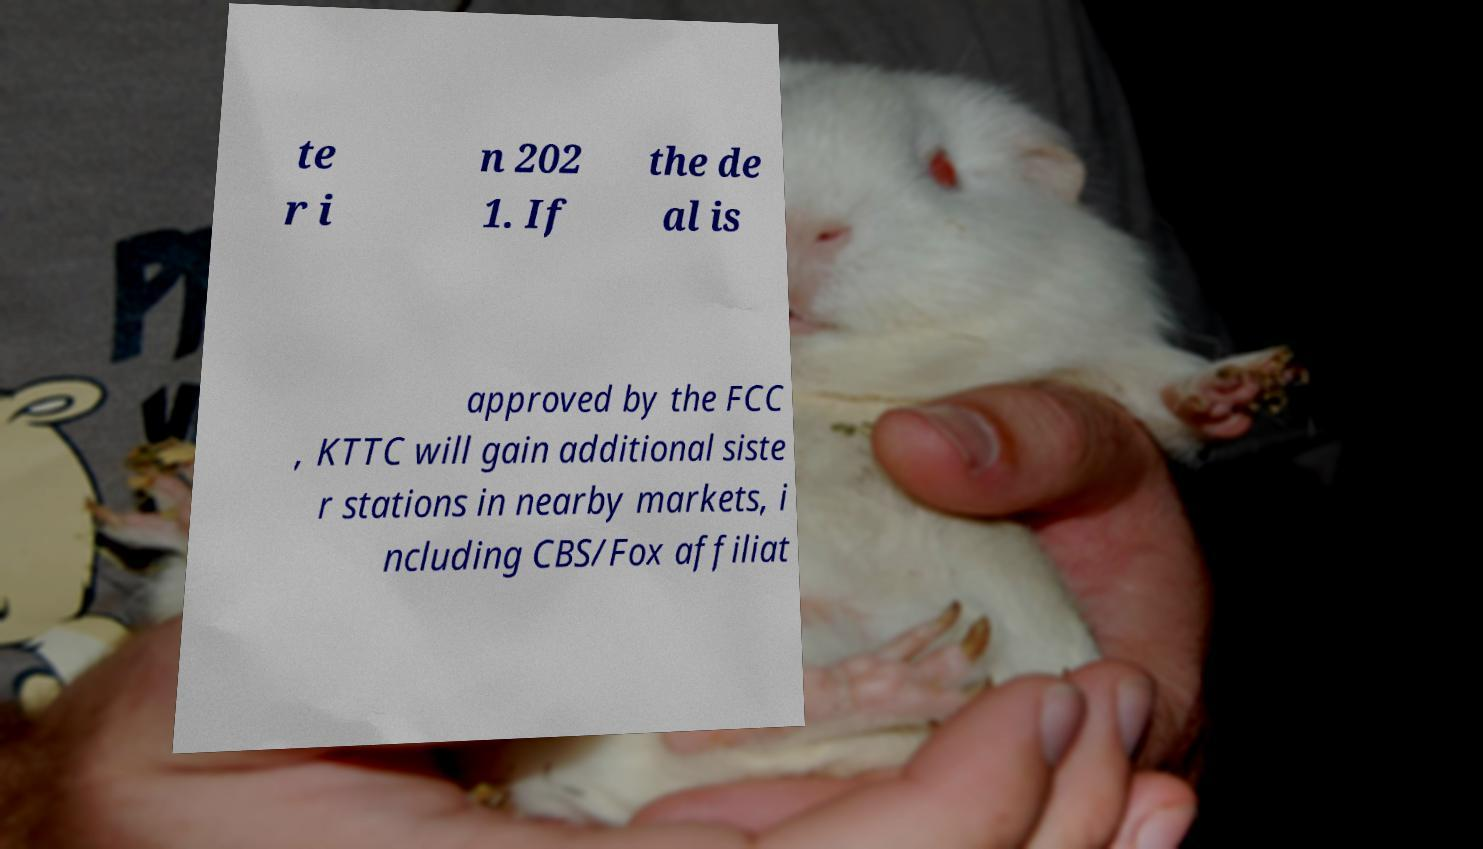Could you assist in decoding the text presented in this image and type it out clearly? te r i n 202 1. If the de al is approved by the FCC , KTTC will gain additional siste r stations in nearby markets, i ncluding CBS/Fox affiliat 